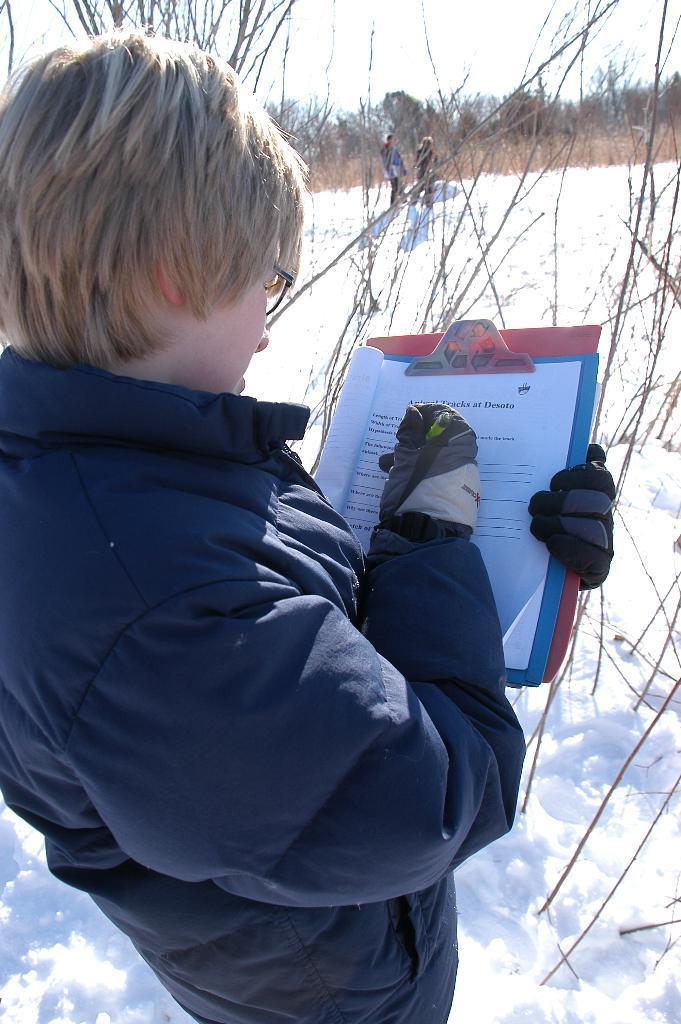Please provide a concise description of this image. In this image there is a person holding a pad with some papers on it and he is standing on the snow, in front of him there are dry trees, behind that there are two people standing. In the background there are trees and the sky. 